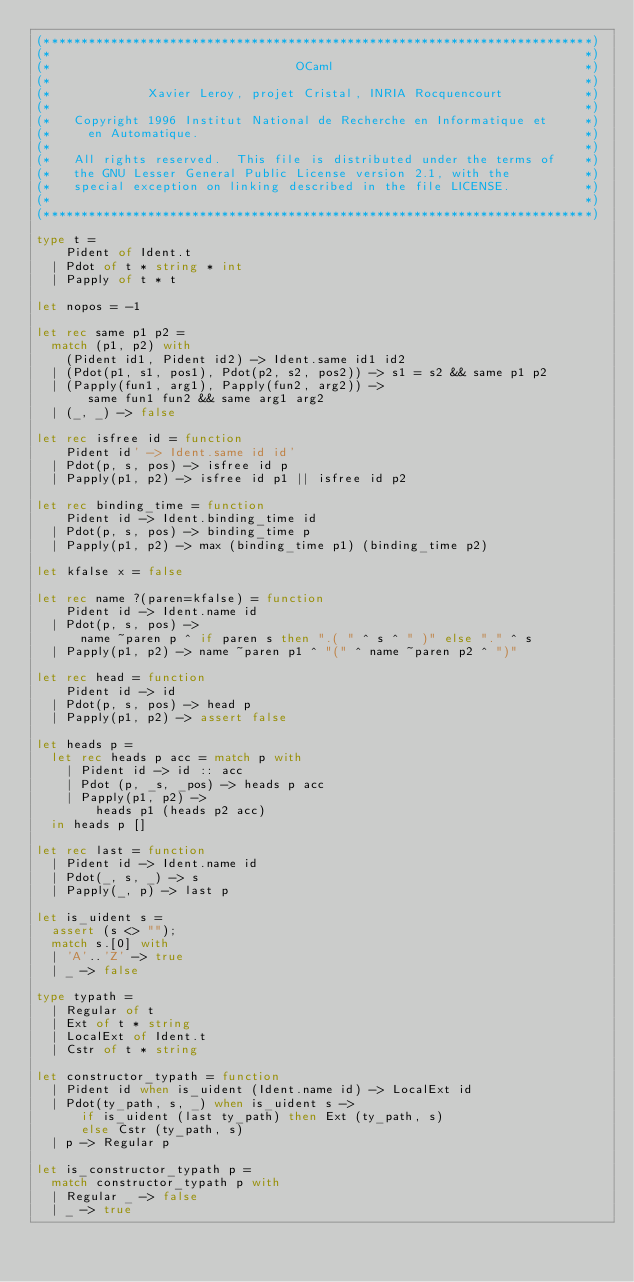Convert code to text. <code><loc_0><loc_0><loc_500><loc_500><_OCaml_>(**************************************************************************)
(*                                                                        *)
(*                                 OCaml                                  *)
(*                                                                        *)
(*             Xavier Leroy, projet Cristal, INRIA Rocquencourt           *)
(*                                                                        *)
(*   Copyright 1996 Institut National de Recherche en Informatique et     *)
(*     en Automatique.                                                    *)
(*                                                                        *)
(*   All rights reserved.  This file is distributed under the terms of    *)
(*   the GNU Lesser General Public License version 2.1, with the          *)
(*   special exception on linking described in the file LICENSE.          *)
(*                                                                        *)
(**************************************************************************)

type t =
    Pident of Ident.t
  | Pdot of t * string * int
  | Papply of t * t

let nopos = -1

let rec same p1 p2 =
  match (p1, p2) with
    (Pident id1, Pident id2) -> Ident.same id1 id2
  | (Pdot(p1, s1, pos1), Pdot(p2, s2, pos2)) -> s1 = s2 && same p1 p2
  | (Papply(fun1, arg1), Papply(fun2, arg2)) ->
       same fun1 fun2 && same arg1 arg2
  | (_, _) -> false

let rec isfree id = function
    Pident id' -> Ident.same id id'
  | Pdot(p, s, pos) -> isfree id p
  | Papply(p1, p2) -> isfree id p1 || isfree id p2

let rec binding_time = function
    Pident id -> Ident.binding_time id
  | Pdot(p, s, pos) -> binding_time p
  | Papply(p1, p2) -> max (binding_time p1) (binding_time p2)

let kfalse x = false

let rec name ?(paren=kfalse) = function
    Pident id -> Ident.name id
  | Pdot(p, s, pos) ->
      name ~paren p ^ if paren s then ".( " ^ s ^ " )" else "." ^ s
  | Papply(p1, p2) -> name ~paren p1 ^ "(" ^ name ~paren p2 ^ ")"

let rec head = function
    Pident id -> id
  | Pdot(p, s, pos) -> head p
  | Papply(p1, p2) -> assert false

let heads p =
  let rec heads p acc = match p with
    | Pident id -> id :: acc
    | Pdot (p, _s, _pos) -> heads p acc
    | Papply(p1, p2) ->
        heads p1 (heads p2 acc)
  in heads p []

let rec last = function
  | Pident id -> Ident.name id
  | Pdot(_, s, _) -> s
  | Papply(_, p) -> last p

let is_uident s =
  assert (s <> "");
  match s.[0] with
  | 'A'..'Z' -> true
  | _ -> false

type typath =
  | Regular of t
  | Ext of t * string
  | LocalExt of Ident.t
  | Cstr of t * string

let constructor_typath = function
  | Pident id when is_uident (Ident.name id) -> LocalExt id
  | Pdot(ty_path, s, _) when is_uident s ->
      if is_uident (last ty_path) then Ext (ty_path, s)
      else Cstr (ty_path, s)
  | p -> Regular p

let is_constructor_typath p =
  match constructor_typath p with
  | Regular _ -> false
  | _ -> true
</code> 